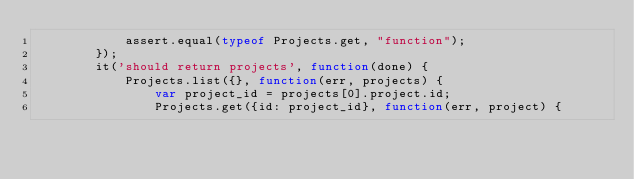<code> <loc_0><loc_0><loc_500><loc_500><_JavaScript_>            assert.equal(typeof Projects.get, "function");
        });
        it('should return projects', function(done) {
            Projects.list({}, function(err, projects) {
                var project_id = projects[0].project.id;
                Projects.get({id: project_id}, function(err, project) {</code> 